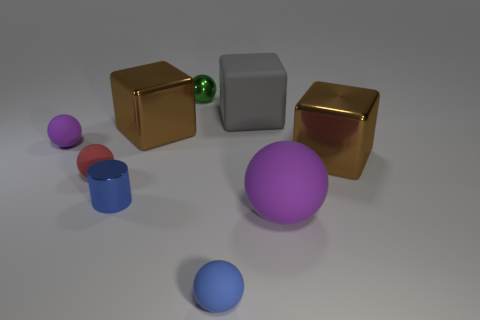What material is the brown block that is on the right side of the gray rubber cube in front of the green metal sphere?
Your answer should be compact. Metal. What shape is the tiny matte thing that is the same color as the big ball?
Your answer should be compact. Sphere. There is a blue shiny object that is the same size as the red sphere; what is its shape?
Make the answer very short. Cylinder. Is the number of spheres less than the number of big blue shiny things?
Ensure brevity in your answer.  No. Are there any rubber balls behind the big metallic thing on the left side of the big gray rubber cube?
Offer a terse response. No. There is a large purple thing that is the same material as the big gray cube; what shape is it?
Your answer should be very brief. Sphere. Is there anything else of the same color as the big sphere?
Keep it short and to the point. Yes. There is a small blue thing that is the same shape as the tiny purple object; what is its material?
Make the answer very short. Rubber. How many other objects are the same size as the red thing?
Your answer should be very brief. 4. There is a matte ball that is the same color as the small shiny cylinder; what size is it?
Offer a very short reply. Small. 